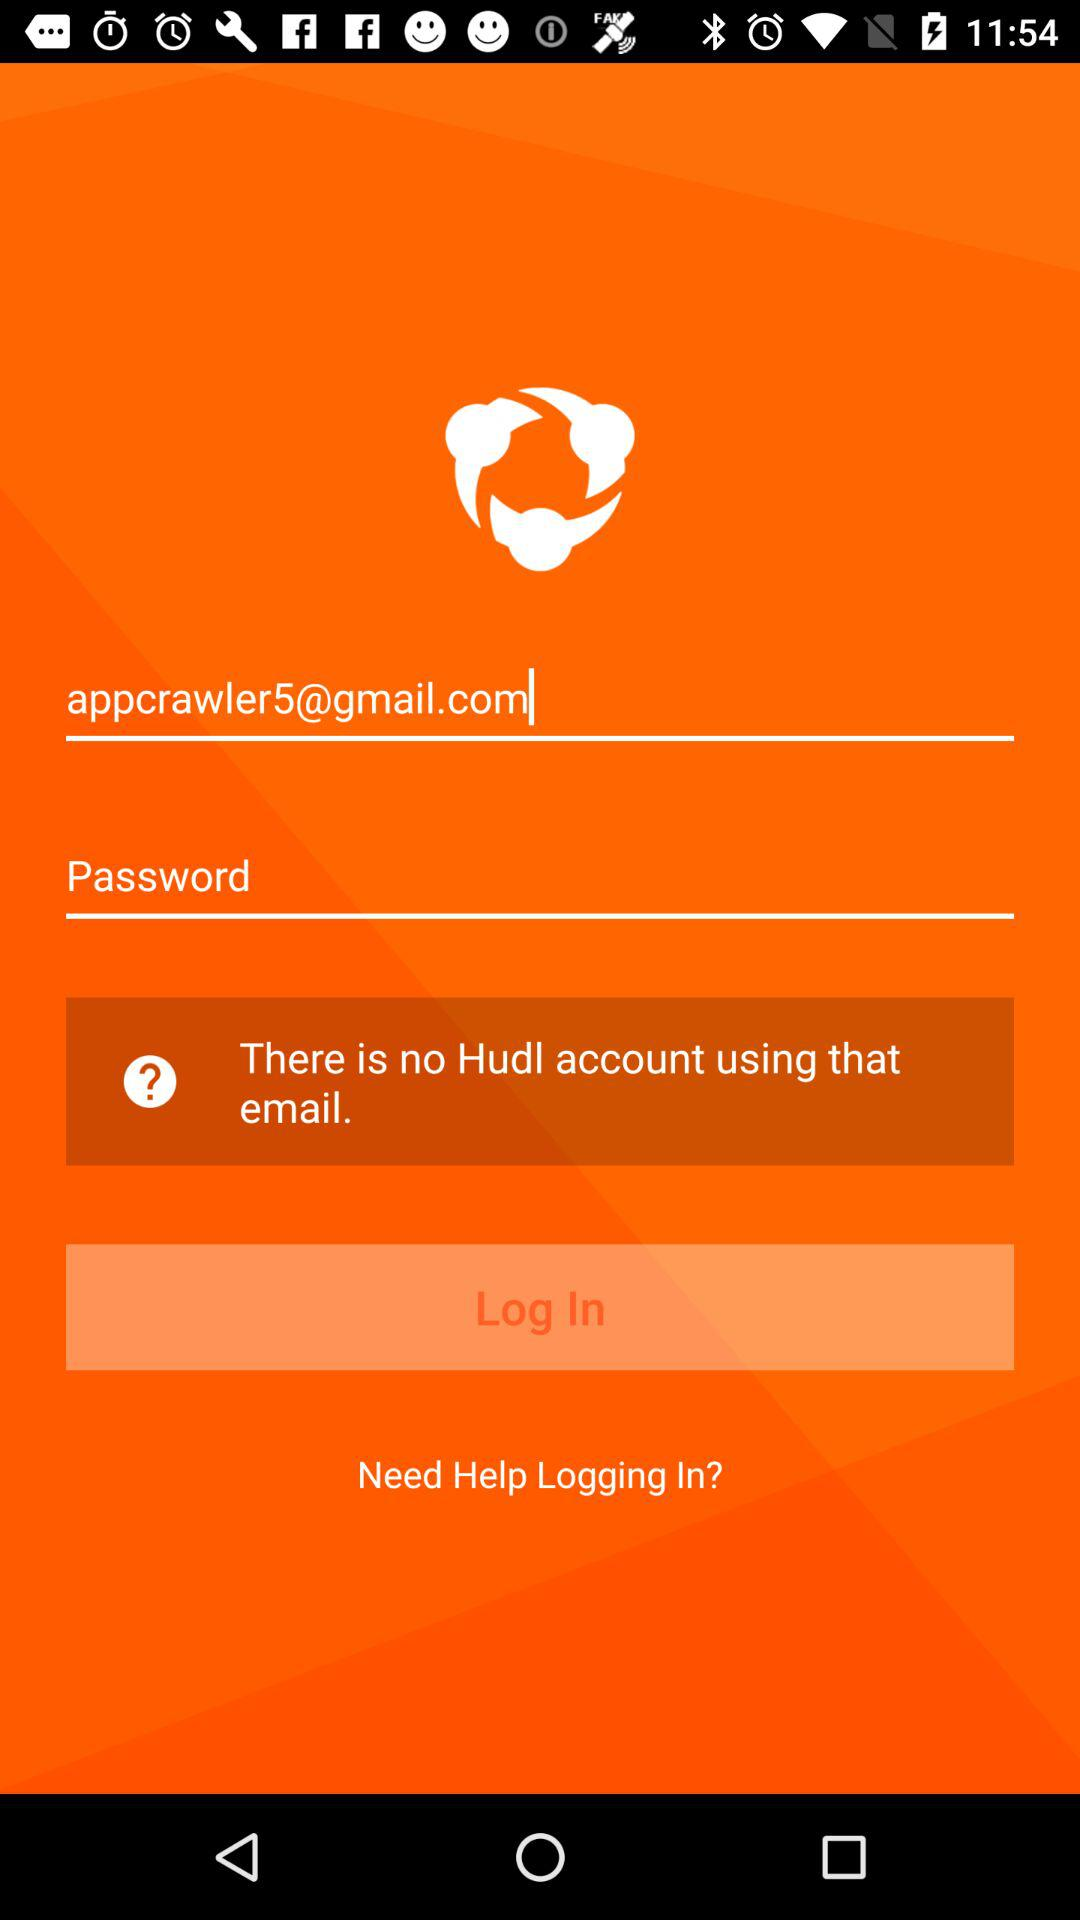What is the email address? The email address is appcrawler5@gmail.com. 